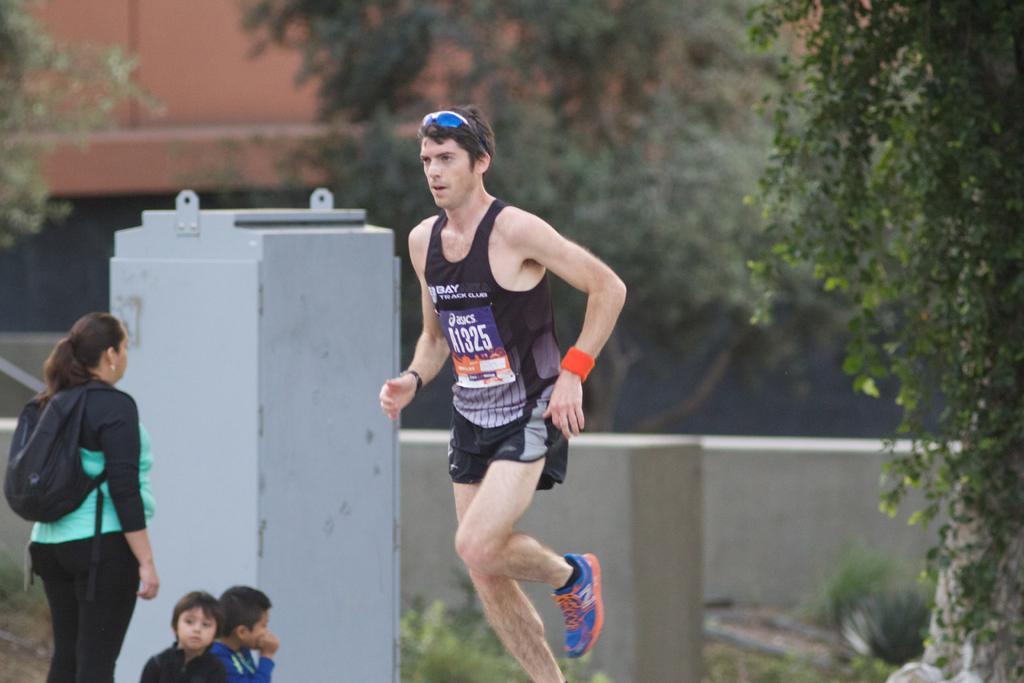Could you give a brief overview of what you see in this image? In this image I can see in the middle a man is running, on the right side there are trees. On the left side there is a woman, at the bottom there are two kids, at the back side there is the wall. 